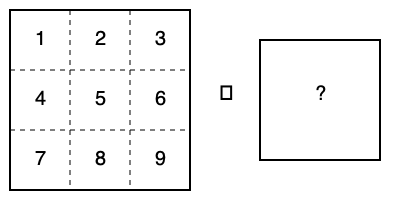The diagram shows a net of a cube with numbered faces. When folded into a cube, which number will be on the opposite face to the number 5? To determine which number is on the opposite face of 5 when the net is folded into a cube, follow these steps:

1. Identify the center face: In this net, face 5 is at the center.
2. Locate adjacent faces: Faces 2, 4, 6, and 8 are adjacent to face 5.
3. Identify the remaining face: Face 7 is the only face not adjacent to face 5.
4. Visualize the folding: When the net is folded into a cube, face 7 will be on the opposite side of face 5.

In a cube, opposite faces are always separated by one face in each direction. Face 7 is the only face that meets this criterion relative to face 5 in the given net.
Answer: 7 